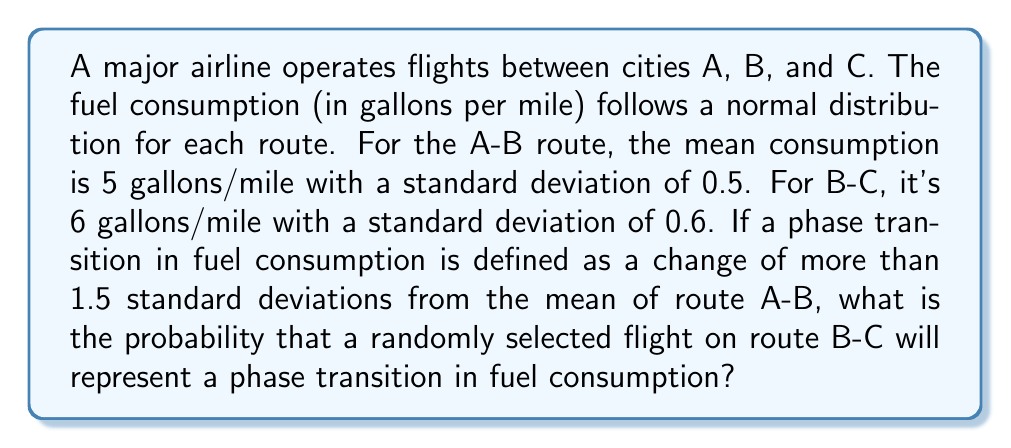What is the answer to this math problem? To solve this problem, we'll follow these steps:

1) First, let's define our variables:
   $\mu_{AB} = 5$ (mean for route A-B)
   $\sigma_{AB} = 0.5$ (standard deviation for route A-B)
   $\mu_{BC} = 6$ (mean for route B-C)
   $\sigma_{BC} = 0.6$ (standard deviation for route B-C)

2) A phase transition is defined as a change of more than 1.5 standard deviations from the mean of route A-B. Let's calculate this threshold:

   Threshold = $\mu_{AB} + 1.5\sigma_{AB} = 5 + 1.5(0.5) = 5.75$

3) Now, we need to find the probability that a flight on route B-C will have fuel consumption above this threshold.

4) To do this, we need to standardize the threshold value for the B-C distribution:

   $z = \frac{x - \mu}{\sigma} = \frac{5.75 - 6}{0.6} = -0.4167$

5) We want the probability of being above this z-score. In a normal distribution, this is equal to 1 minus the cumulative probability up to this z-score:

   $P(X > 5.75) = 1 - P(X \leq 5.75) = 1 - \Phi(-0.4167)$

   Where $\Phi$ is the cumulative distribution function of the standard normal distribution.

6) Using a standard normal table or calculator:

   $\Phi(-0.4167) \approx 0.3384$

7) Therefore, the probability we're looking for is:

   $1 - 0.3384 = 0.6616$
Answer: 0.6616 